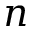<formula> <loc_0><loc_0><loc_500><loc_500>n</formula> 